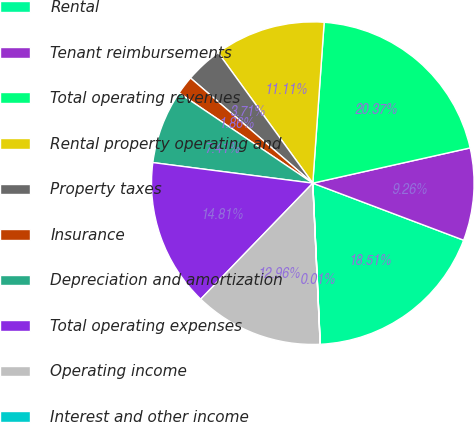<chart> <loc_0><loc_0><loc_500><loc_500><pie_chart><fcel>Rental<fcel>Tenant reimbursements<fcel>Total operating revenues<fcel>Rental property operating and<fcel>Property taxes<fcel>Insurance<fcel>Depreciation and amortization<fcel>Total operating expenses<fcel>Operating income<fcel>Interest and other income<nl><fcel>18.51%<fcel>9.26%<fcel>20.37%<fcel>11.11%<fcel>3.71%<fcel>1.86%<fcel>7.41%<fcel>14.81%<fcel>12.96%<fcel>0.01%<nl></chart> 